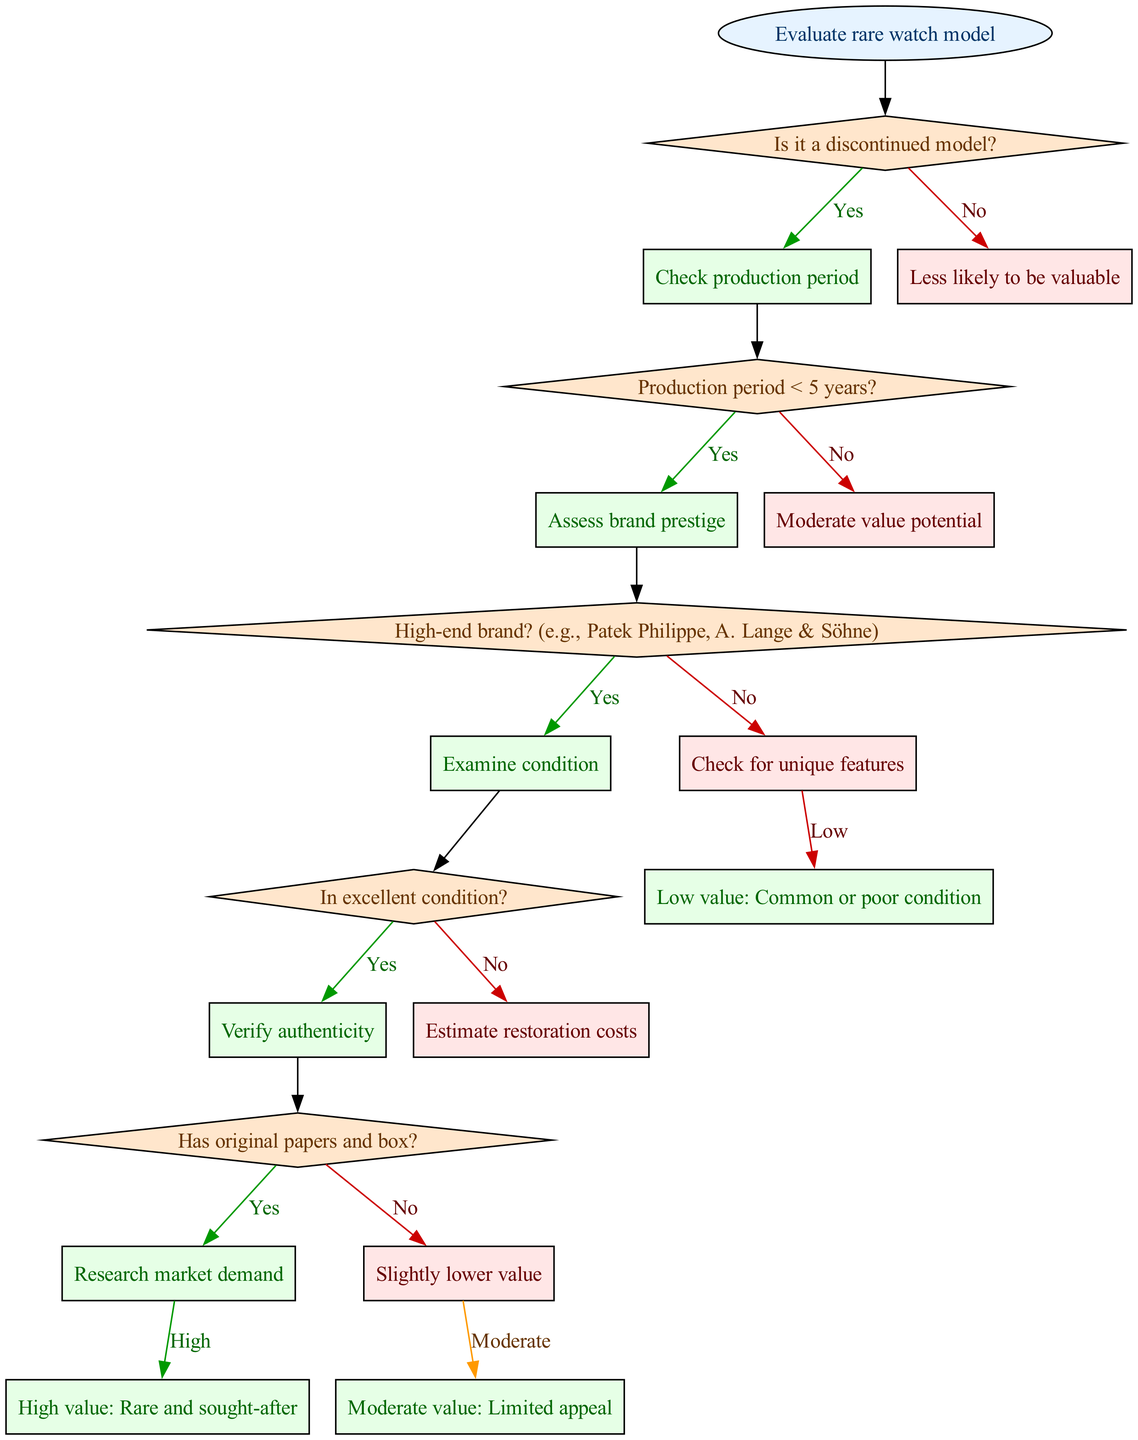What is the first question in the decision tree? The first question in the decision tree is "Is it a discontinued model?" as indicated directly from the start node leading to the first decision node.
Answer: Is it a discontinued model? How many decision nodes are there in total? The diagram lists five decision nodes, each corresponding to a question that narrows down the potential value of the watch.
Answer: Five What is the outcome if the watch is in excellent condition? If the watch is in excellent condition, the next step is to "Verify authenticity," which will lead to an end node based on the following evaluations.
Answer: Verify authenticity What follows after "Check production period"? After "Check production period," the decision tree leads to "Production period < 5 years?" which further determines value based on the production time.
Answer: Production period < 5 years? If the answer to "Has original papers and box?" is no, what happens next? If the answer is no, the decision flow directs to "Slightly lower value," which signifies that not having original papers and box impacts the watch's value negatively.
Answer: Slightly lower value What does the node "High value: Rare and sought-after" represent in the context of the decision tree? The node "High value: Rare and sought-after" indicates that if all preceding conditions are met positively, the watch achieves a high value status based on rarity and demand.
Answer: High value: Rare and sought-after Which node indicates "Moderate value" and under what conditions might a watch end up here? The "Moderate value: Limited appeal" node is reached if the production period is not less than five years and the condition or authenticity is not affirmed positively.
Answer: Moderate value: Limited appeal What color are the decision nodes in the diagram? The decision nodes are colored in a light orange shade, specifically filled with '#FFE6CC', as per the diagram's design choices for clarity.
Answer: Light orange What direction do you take if the watch is a high-end brand? If the watch is identified as a high-end brand, the subsequent step is to "Examine condition," indicating a focus on the physical state of the watch following brand prestige recognition.
Answer: Examine condition 